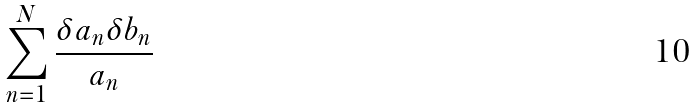Convert formula to latex. <formula><loc_0><loc_0><loc_500><loc_500>\sum _ { n = 1 } ^ { N } \frac { \delta a _ { n } \delta b _ { n } } { a _ { n } }</formula> 